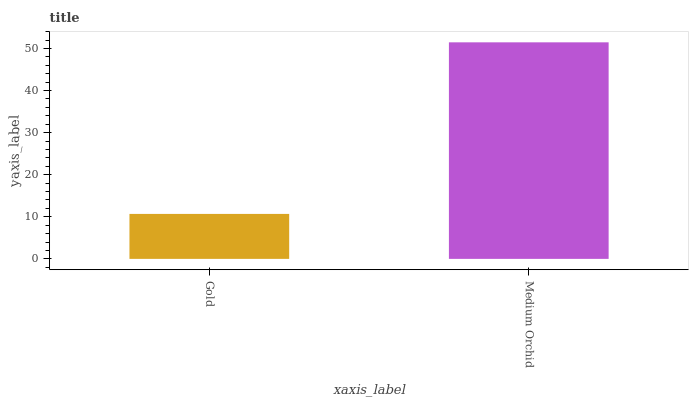Is Gold the minimum?
Answer yes or no. Yes. Is Medium Orchid the maximum?
Answer yes or no. Yes. Is Medium Orchid the minimum?
Answer yes or no. No. Is Medium Orchid greater than Gold?
Answer yes or no. Yes. Is Gold less than Medium Orchid?
Answer yes or no. Yes. Is Gold greater than Medium Orchid?
Answer yes or no. No. Is Medium Orchid less than Gold?
Answer yes or no. No. Is Medium Orchid the high median?
Answer yes or no. Yes. Is Gold the low median?
Answer yes or no. Yes. Is Gold the high median?
Answer yes or no. No. Is Medium Orchid the low median?
Answer yes or no. No. 